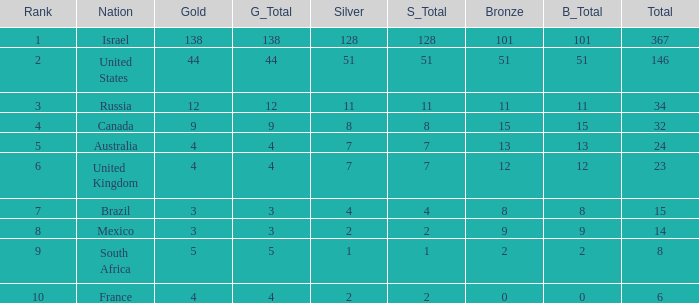What is the maximum number of silvers for a country with fewer than 12 golds and a total less than 8? 2.0. 